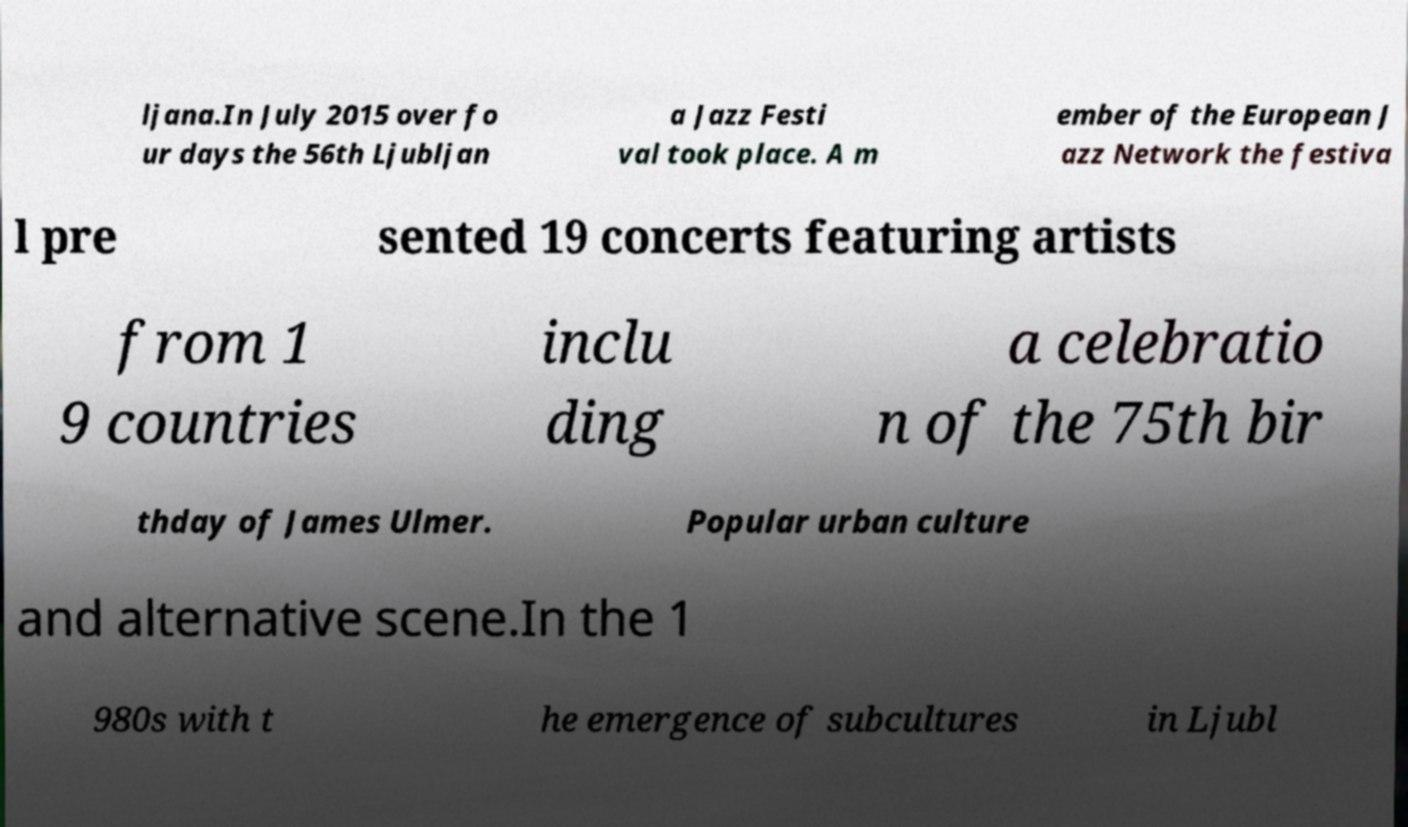Could you extract and type out the text from this image? ljana.In July 2015 over fo ur days the 56th Ljubljan a Jazz Festi val took place. A m ember of the European J azz Network the festiva l pre sented 19 concerts featuring artists from 1 9 countries inclu ding a celebratio n of the 75th bir thday of James Ulmer. Popular urban culture and alternative scene.In the 1 980s with t he emergence of subcultures in Ljubl 